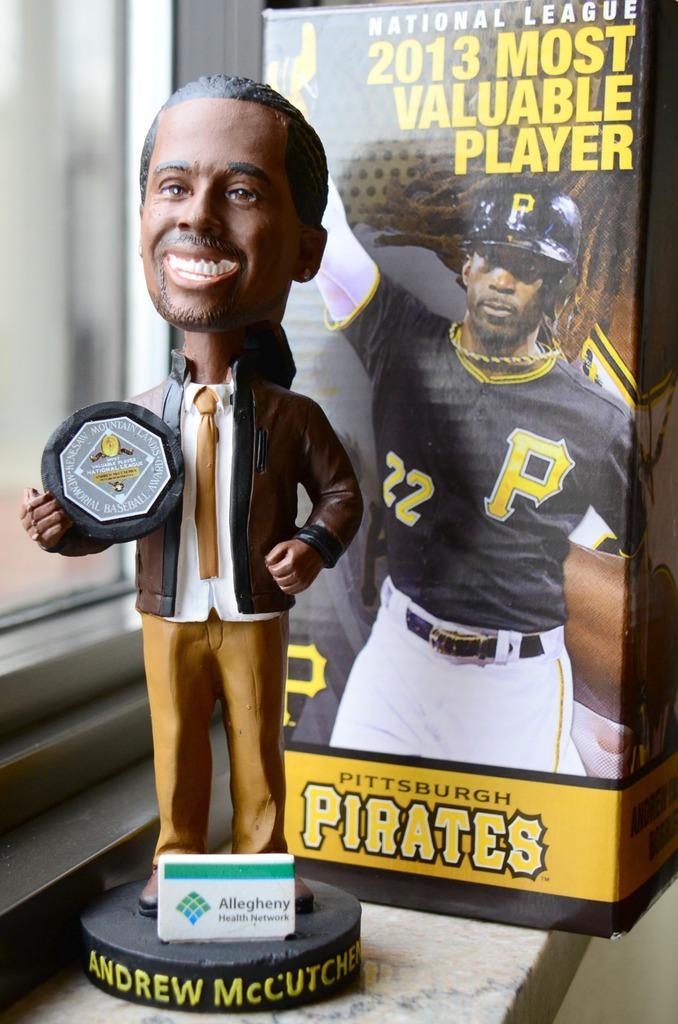Could you give a brief overview of what you see in this image? In this picture we can see a statue of a man holding an objects and we can see board and text on the platform, behind this statue we can see banner. We can see glass window. 